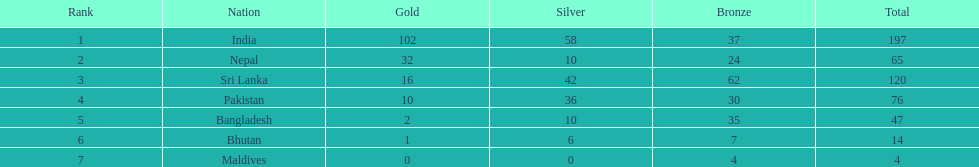Name a country listed in the table, other than india? Nepal. 